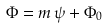<formula> <loc_0><loc_0><loc_500><loc_500>\Phi = m \, \psi + \Phi _ { 0 }</formula> 